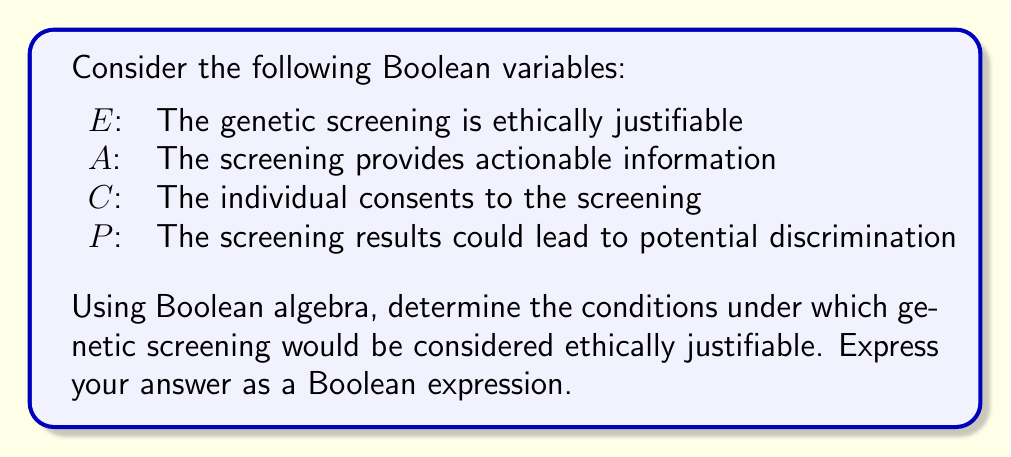Show me your answer to this math problem. To approach this problem from a philosophical perspective, we need to consider the ethical implications of genetic screening and translate them into Boolean logic. Let's break it down step-by-step:

1. For genetic screening to be ethically justifiable ($E$), we can argue that it should provide actionable information ($A$) and have the individual's consent ($C$).

2. However, even with actionable information and consent, if the screening could lead to potential discrimination ($P$), it might not be ethically justifiable.

3. We can express this logic using Boolean algebra:
   $E = (A \land C) \land \lnot P$

4. This expression can be read as: Genetic screening is ethically justifiable if and only if it provides actionable information AND has the individual's consent AND does NOT lead to potential discrimination.

5. We can simplify this expression using the distributive property:
   $E = A \land C \land \lnot P$

6. This Boolean expression encapsulates the ethical considerations of genetic screening, balancing the potential benefits (actionable information) with the requirements of autonomy (consent) and the avoidance of harm (non-discrimination).

From a philosophical standpoint, this formulation allows us to examine the interplay between determinism (as represented by genetic information) and ethical decision-making, highlighting the complexity of applying ethical principles to advances in genetic science.
Answer: $E = A \land C \land \lnot P$ 